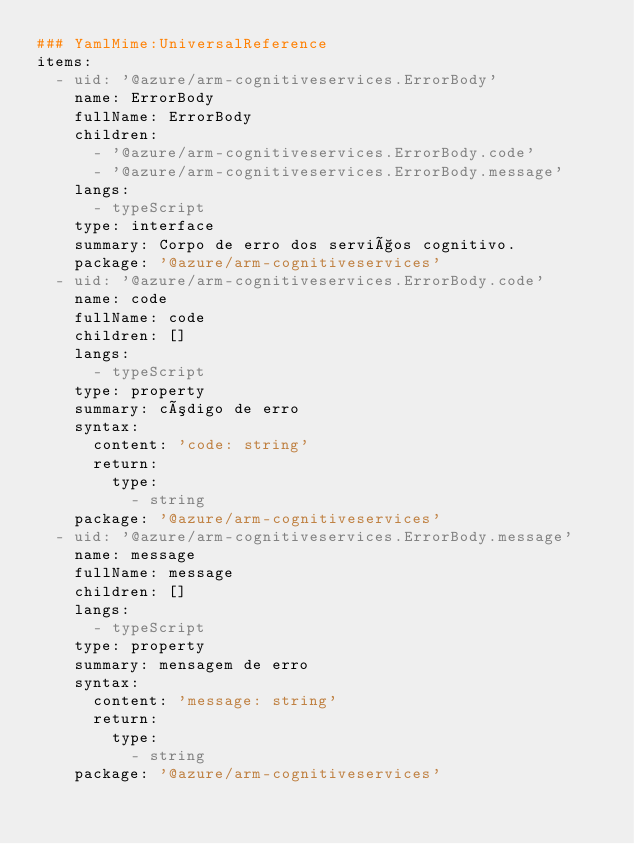<code> <loc_0><loc_0><loc_500><loc_500><_YAML_>### YamlMime:UniversalReference
items:
  - uid: '@azure/arm-cognitiveservices.ErrorBody'
    name: ErrorBody
    fullName: ErrorBody
    children:
      - '@azure/arm-cognitiveservices.ErrorBody.code'
      - '@azure/arm-cognitiveservices.ErrorBody.message'
    langs:
      - typeScript
    type: interface
    summary: Corpo de erro dos serviços cognitivo.
    package: '@azure/arm-cognitiveservices'
  - uid: '@azure/arm-cognitiveservices.ErrorBody.code'
    name: code
    fullName: code
    children: []
    langs:
      - typeScript
    type: property
    summary: código de erro
    syntax:
      content: 'code: string'
      return:
        type:
          - string
    package: '@azure/arm-cognitiveservices'
  - uid: '@azure/arm-cognitiveservices.ErrorBody.message'
    name: message
    fullName: message
    children: []
    langs:
      - typeScript
    type: property
    summary: mensagem de erro
    syntax:
      content: 'message: string'
      return:
        type:
          - string
    package: '@azure/arm-cognitiveservices'</code> 